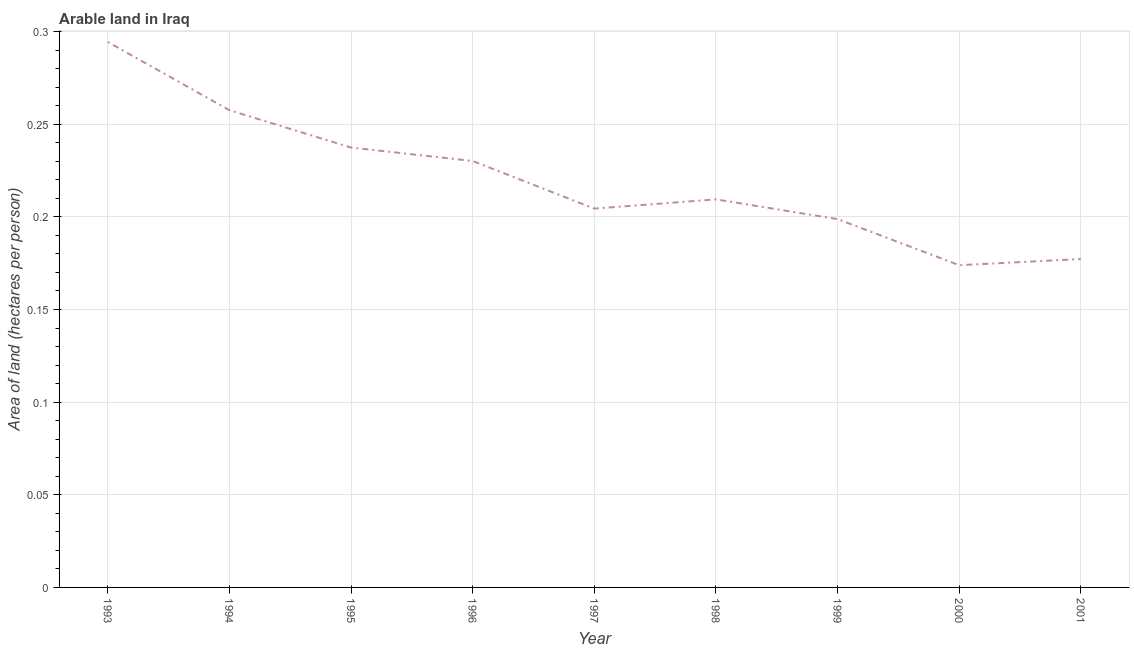What is the area of arable land in 1998?
Your answer should be very brief. 0.21. Across all years, what is the maximum area of arable land?
Your answer should be very brief. 0.29. Across all years, what is the minimum area of arable land?
Make the answer very short. 0.17. What is the sum of the area of arable land?
Provide a short and direct response. 1.98. What is the difference between the area of arable land in 1993 and 2001?
Your answer should be very brief. 0.12. What is the average area of arable land per year?
Give a very brief answer. 0.22. What is the median area of arable land?
Your response must be concise. 0.21. In how many years, is the area of arable land greater than 0.29 hectares per person?
Give a very brief answer. 1. What is the ratio of the area of arable land in 1993 to that in 1995?
Ensure brevity in your answer.  1.24. Is the area of arable land in 1996 less than that in 2000?
Keep it short and to the point. No. Is the difference between the area of arable land in 1995 and 2000 greater than the difference between any two years?
Give a very brief answer. No. What is the difference between the highest and the second highest area of arable land?
Make the answer very short. 0.04. What is the difference between the highest and the lowest area of arable land?
Offer a very short reply. 0.12. In how many years, is the area of arable land greater than the average area of arable land taken over all years?
Provide a short and direct response. 4. How many years are there in the graph?
Give a very brief answer. 9. What is the difference between two consecutive major ticks on the Y-axis?
Keep it short and to the point. 0.05. Are the values on the major ticks of Y-axis written in scientific E-notation?
Give a very brief answer. No. What is the title of the graph?
Your answer should be compact. Arable land in Iraq. What is the label or title of the Y-axis?
Make the answer very short. Area of land (hectares per person). What is the Area of land (hectares per person) in 1993?
Your answer should be compact. 0.29. What is the Area of land (hectares per person) of 1994?
Your answer should be very brief. 0.26. What is the Area of land (hectares per person) of 1995?
Your answer should be very brief. 0.24. What is the Area of land (hectares per person) of 1996?
Ensure brevity in your answer.  0.23. What is the Area of land (hectares per person) of 1997?
Provide a short and direct response. 0.2. What is the Area of land (hectares per person) of 1998?
Offer a very short reply. 0.21. What is the Area of land (hectares per person) of 1999?
Offer a very short reply. 0.2. What is the Area of land (hectares per person) of 2000?
Your response must be concise. 0.17. What is the Area of land (hectares per person) in 2001?
Offer a very short reply. 0.18. What is the difference between the Area of land (hectares per person) in 1993 and 1994?
Keep it short and to the point. 0.04. What is the difference between the Area of land (hectares per person) in 1993 and 1995?
Your response must be concise. 0.06. What is the difference between the Area of land (hectares per person) in 1993 and 1996?
Your answer should be very brief. 0.06. What is the difference between the Area of land (hectares per person) in 1993 and 1997?
Offer a very short reply. 0.09. What is the difference between the Area of land (hectares per person) in 1993 and 1998?
Offer a very short reply. 0.08. What is the difference between the Area of land (hectares per person) in 1993 and 1999?
Provide a succinct answer. 0.1. What is the difference between the Area of land (hectares per person) in 1993 and 2000?
Your answer should be very brief. 0.12. What is the difference between the Area of land (hectares per person) in 1993 and 2001?
Provide a short and direct response. 0.12. What is the difference between the Area of land (hectares per person) in 1994 and 1995?
Keep it short and to the point. 0.02. What is the difference between the Area of land (hectares per person) in 1994 and 1996?
Your response must be concise. 0.03. What is the difference between the Area of land (hectares per person) in 1994 and 1997?
Offer a very short reply. 0.05. What is the difference between the Area of land (hectares per person) in 1994 and 1998?
Your response must be concise. 0.05. What is the difference between the Area of land (hectares per person) in 1994 and 1999?
Offer a very short reply. 0.06. What is the difference between the Area of land (hectares per person) in 1994 and 2000?
Make the answer very short. 0.08. What is the difference between the Area of land (hectares per person) in 1994 and 2001?
Offer a very short reply. 0.08. What is the difference between the Area of land (hectares per person) in 1995 and 1996?
Provide a short and direct response. 0.01. What is the difference between the Area of land (hectares per person) in 1995 and 1997?
Ensure brevity in your answer.  0.03. What is the difference between the Area of land (hectares per person) in 1995 and 1998?
Ensure brevity in your answer.  0.03. What is the difference between the Area of land (hectares per person) in 1995 and 1999?
Provide a short and direct response. 0.04. What is the difference between the Area of land (hectares per person) in 1995 and 2000?
Provide a short and direct response. 0.06. What is the difference between the Area of land (hectares per person) in 1995 and 2001?
Your answer should be compact. 0.06. What is the difference between the Area of land (hectares per person) in 1996 and 1997?
Provide a short and direct response. 0.03. What is the difference between the Area of land (hectares per person) in 1996 and 1998?
Give a very brief answer. 0.02. What is the difference between the Area of land (hectares per person) in 1996 and 1999?
Provide a short and direct response. 0.03. What is the difference between the Area of land (hectares per person) in 1996 and 2000?
Your answer should be very brief. 0.06. What is the difference between the Area of land (hectares per person) in 1996 and 2001?
Your answer should be compact. 0.05. What is the difference between the Area of land (hectares per person) in 1997 and 1998?
Provide a succinct answer. -0. What is the difference between the Area of land (hectares per person) in 1997 and 1999?
Keep it short and to the point. 0.01. What is the difference between the Area of land (hectares per person) in 1997 and 2000?
Make the answer very short. 0.03. What is the difference between the Area of land (hectares per person) in 1997 and 2001?
Your answer should be compact. 0.03. What is the difference between the Area of land (hectares per person) in 1998 and 1999?
Offer a terse response. 0.01. What is the difference between the Area of land (hectares per person) in 1998 and 2000?
Make the answer very short. 0.04. What is the difference between the Area of land (hectares per person) in 1998 and 2001?
Your answer should be very brief. 0.03. What is the difference between the Area of land (hectares per person) in 1999 and 2000?
Provide a short and direct response. 0.02. What is the difference between the Area of land (hectares per person) in 1999 and 2001?
Give a very brief answer. 0.02. What is the difference between the Area of land (hectares per person) in 2000 and 2001?
Keep it short and to the point. -0. What is the ratio of the Area of land (hectares per person) in 1993 to that in 1994?
Your answer should be very brief. 1.14. What is the ratio of the Area of land (hectares per person) in 1993 to that in 1995?
Offer a very short reply. 1.24. What is the ratio of the Area of land (hectares per person) in 1993 to that in 1996?
Offer a terse response. 1.28. What is the ratio of the Area of land (hectares per person) in 1993 to that in 1997?
Your answer should be compact. 1.44. What is the ratio of the Area of land (hectares per person) in 1993 to that in 1998?
Your answer should be very brief. 1.41. What is the ratio of the Area of land (hectares per person) in 1993 to that in 1999?
Provide a short and direct response. 1.48. What is the ratio of the Area of land (hectares per person) in 1993 to that in 2000?
Your response must be concise. 1.69. What is the ratio of the Area of land (hectares per person) in 1993 to that in 2001?
Give a very brief answer. 1.66. What is the ratio of the Area of land (hectares per person) in 1994 to that in 1995?
Your response must be concise. 1.08. What is the ratio of the Area of land (hectares per person) in 1994 to that in 1996?
Offer a very short reply. 1.12. What is the ratio of the Area of land (hectares per person) in 1994 to that in 1997?
Your answer should be very brief. 1.26. What is the ratio of the Area of land (hectares per person) in 1994 to that in 1998?
Keep it short and to the point. 1.23. What is the ratio of the Area of land (hectares per person) in 1994 to that in 1999?
Your response must be concise. 1.3. What is the ratio of the Area of land (hectares per person) in 1994 to that in 2000?
Your answer should be very brief. 1.48. What is the ratio of the Area of land (hectares per person) in 1994 to that in 2001?
Your answer should be very brief. 1.45. What is the ratio of the Area of land (hectares per person) in 1995 to that in 1996?
Offer a very short reply. 1.03. What is the ratio of the Area of land (hectares per person) in 1995 to that in 1997?
Keep it short and to the point. 1.16. What is the ratio of the Area of land (hectares per person) in 1995 to that in 1998?
Your answer should be very brief. 1.13. What is the ratio of the Area of land (hectares per person) in 1995 to that in 1999?
Offer a very short reply. 1.19. What is the ratio of the Area of land (hectares per person) in 1995 to that in 2000?
Offer a very short reply. 1.36. What is the ratio of the Area of land (hectares per person) in 1995 to that in 2001?
Ensure brevity in your answer.  1.34. What is the ratio of the Area of land (hectares per person) in 1996 to that in 1997?
Keep it short and to the point. 1.13. What is the ratio of the Area of land (hectares per person) in 1996 to that in 1998?
Your response must be concise. 1.1. What is the ratio of the Area of land (hectares per person) in 1996 to that in 1999?
Give a very brief answer. 1.16. What is the ratio of the Area of land (hectares per person) in 1996 to that in 2000?
Offer a very short reply. 1.32. What is the ratio of the Area of land (hectares per person) in 1996 to that in 2001?
Provide a succinct answer. 1.3. What is the ratio of the Area of land (hectares per person) in 1997 to that in 1999?
Ensure brevity in your answer.  1.03. What is the ratio of the Area of land (hectares per person) in 1997 to that in 2000?
Offer a very short reply. 1.18. What is the ratio of the Area of land (hectares per person) in 1997 to that in 2001?
Your answer should be compact. 1.15. What is the ratio of the Area of land (hectares per person) in 1998 to that in 1999?
Provide a short and direct response. 1.05. What is the ratio of the Area of land (hectares per person) in 1998 to that in 2000?
Provide a short and direct response. 1.2. What is the ratio of the Area of land (hectares per person) in 1998 to that in 2001?
Provide a succinct answer. 1.18. What is the ratio of the Area of land (hectares per person) in 1999 to that in 2000?
Your answer should be compact. 1.14. What is the ratio of the Area of land (hectares per person) in 1999 to that in 2001?
Provide a short and direct response. 1.12. 